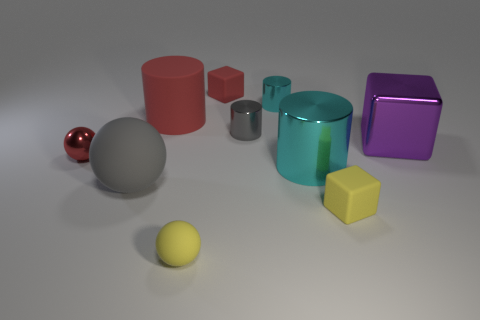Subtract all blue spheres. How many cyan cylinders are left? 2 Subtract all matte cylinders. How many cylinders are left? 3 Subtract 2 cylinders. How many cylinders are left? 2 Subtract all green cylinders. Subtract all yellow balls. How many cylinders are left? 4 Subtract all big red matte blocks. Subtract all yellow rubber blocks. How many objects are left? 9 Add 4 tiny cyan cylinders. How many tiny cyan cylinders are left? 5 Add 6 rubber cylinders. How many rubber cylinders exist? 7 Subtract 0 blue cubes. How many objects are left? 10 Subtract all cylinders. How many objects are left? 6 